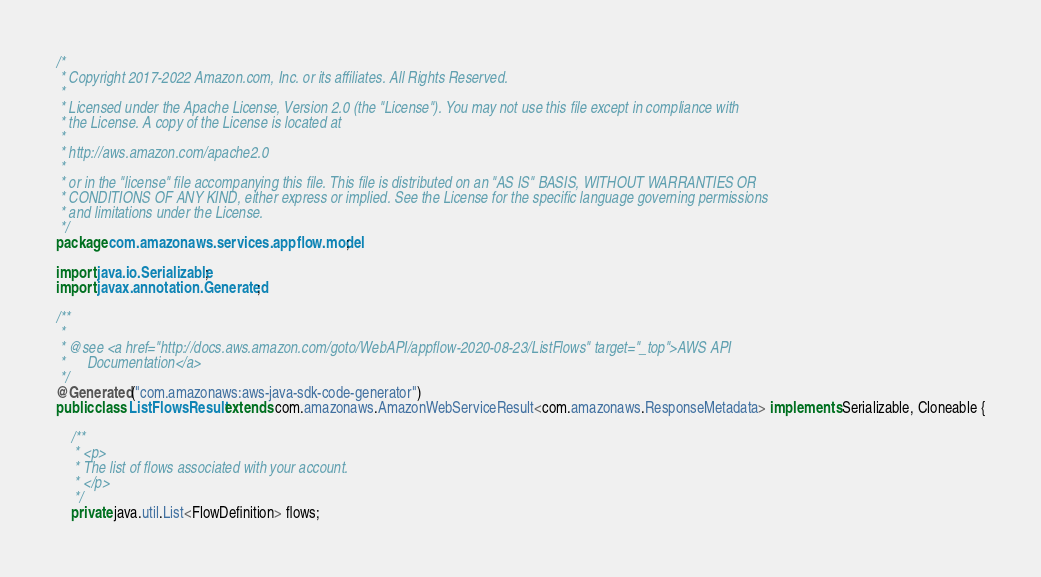Convert code to text. <code><loc_0><loc_0><loc_500><loc_500><_Java_>/*
 * Copyright 2017-2022 Amazon.com, Inc. or its affiliates. All Rights Reserved.
 * 
 * Licensed under the Apache License, Version 2.0 (the "License"). You may not use this file except in compliance with
 * the License. A copy of the License is located at
 * 
 * http://aws.amazon.com/apache2.0
 * 
 * or in the "license" file accompanying this file. This file is distributed on an "AS IS" BASIS, WITHOUT WARRANTIES OR
 * CONDITIONS OF ANY KIND, either express or implied. See the License for the specific language governing permissions
 * and limitations under the License.
 */
package com.amazonaws.services.appflow.model;

import java.io.Serializable;
import javax.annotation.Generated;

/**
 * 
 * @see <a href="http://docs.aws.amazon.com/goto/WebAPI/appflow-2020-08-23/ListFlows" target="_top">AWS API
 *      Documentation</a>
 */
@Generated("com.amazonaws:aws-java-sdk-code-generator")
public class ListFlowsResult extends com.amazonaws.AmazonWebServiceResult<com.amazonaws.ResponseMetadata> implements Serializable, Cloneable {

    /**
     * <p>
     * The list of flows associated with your account.
     * </p>
     */
    private java.util.List<FlowDefinition> flows;</code> 